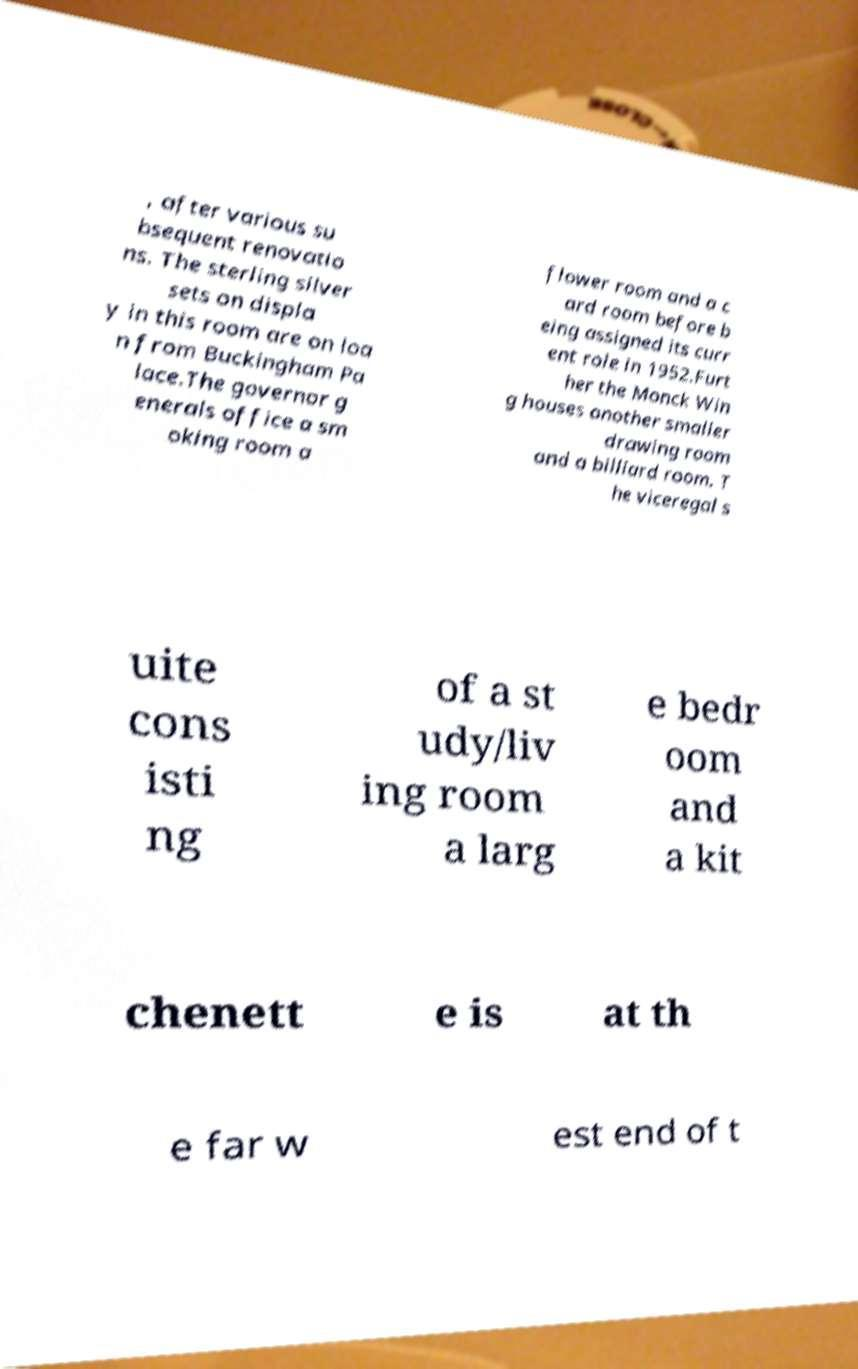Could you extract and type out the text from this image? , after various su bsequent renovatio ns. The sterling silver sets on displa y in this room are on loa n from Buckingham Pa lace.The governor g enerals office a sm oking room a flower room and a c ard room before b eing assigned its curr ent role in 1952.Furt her the Monck Win g houses another smaller drawing room and a billiard room. T he viceregal s uite cons isti ng of a st udy/liv ing room a larg e bedr oom and a kit chenett e is at th e far w est end of t 